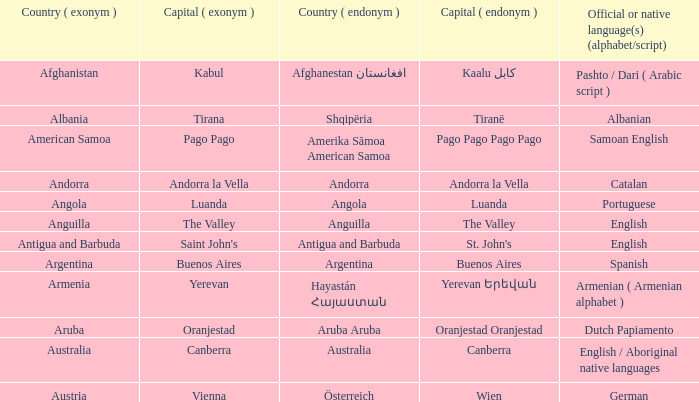Give me the full table as a dictionary. {'header': ['Country ( exonym )', 'Capital ( exonym )', 'Country ( endonym )', 'Capital ( endonym )', 'Official or native language(s) (alphabet/script)'], 'rows': [['Afghanistan', 'Kabul', 'Afghanestan افغانستان', 'Kaalu كابل', 'Pashto / Dari ( Arabic script )'], ['Albania', 'Tirana', 'Shqipëria', 'Tiranë', 'Albanian'], ['American Samoa', 'Pago Pago', 'Amerika Sāmoa American Samoa', 'Pago Pago Pago Pago', 'Samoan English'], ['Andorra', 'Andorra la Vella', 'Andorra', 'Andorra la Vella', 'Catalan'], ['Angola', 'Luanda', 'Angola', 'Luanda', 'Portuguese'], ['Anguilla', 'The Valley', 'Anguilla', 'The Valley', 'English'], ['Antigua and Barbuda', "Saint John's", 'Antigua and Barbuda', "St. John's", 'English'], ['Argentina', 'Buenos Aires', 'Argentina', 'Buenos Aires', 'Spanish'], ['Armenia', 'Yerevan', 'Hayastán Հայաստան', 'Yerevan Երեվան', 'Armenian ( Armenian alphabet )'], ['Aruba', 'Oranjestad', 'Aruba Aruba', 'Oranjestad Oranjestad', 'Dutch Papiamento'], ['Australia', 'Canberra', 'Australia', 'Canberra', 'English / Aboriginal native languages'], ['Austria', 'Vienna', 'Österreich', 'Wien', 'German']]} What english name is assigned to the city known as st. john's? Saint John's. 